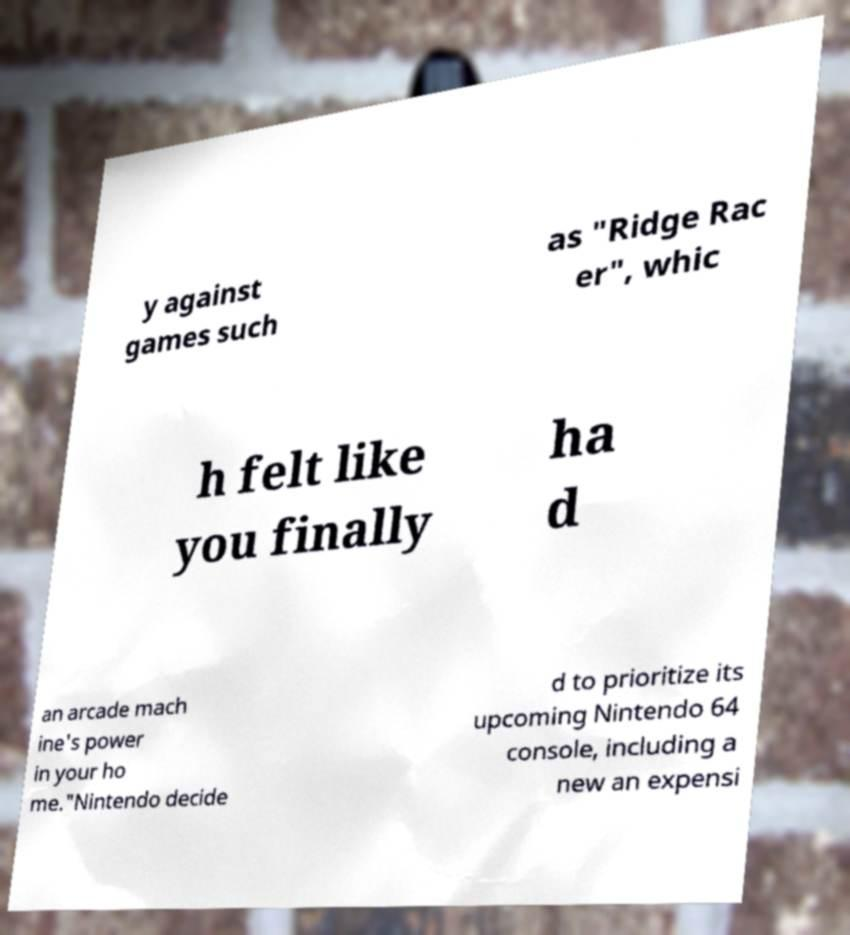Could you assist in decoding the text presented in this image and type it out clearly? y against games such as "Ridge Rac er", whic h felt like you finally ha d an arcade mach ine's power in your ho me."Nintendo decide d to prioritize its upcoming Nintendo 64 console, including a new an expensi 